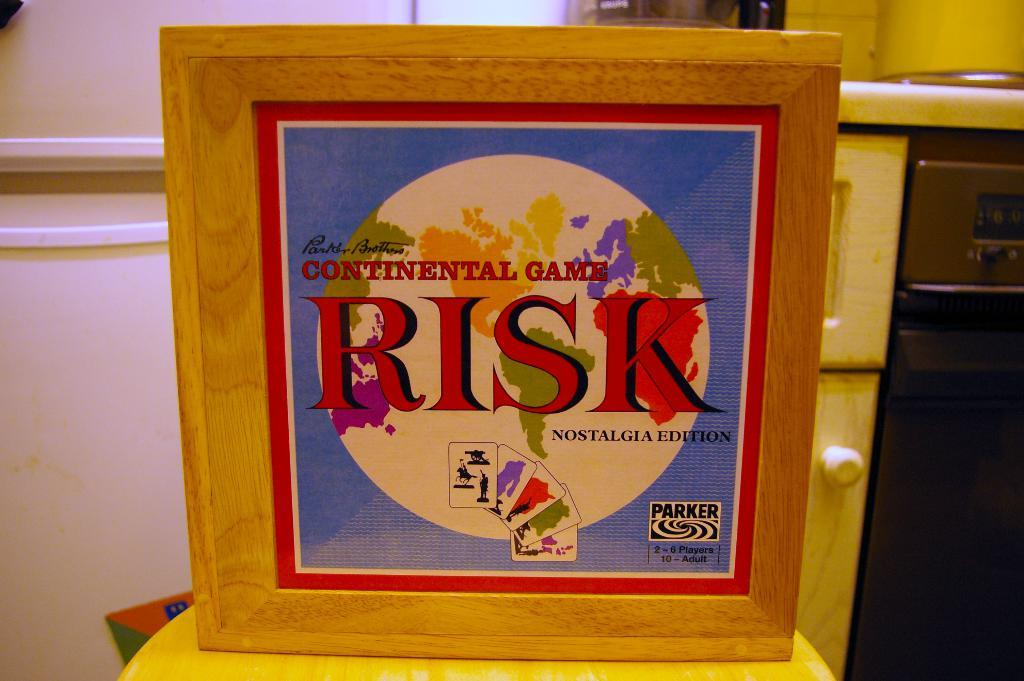<image>
Present a compact description of the photo's key features. The game Risk by Parker Brothers for 2-6 players. 